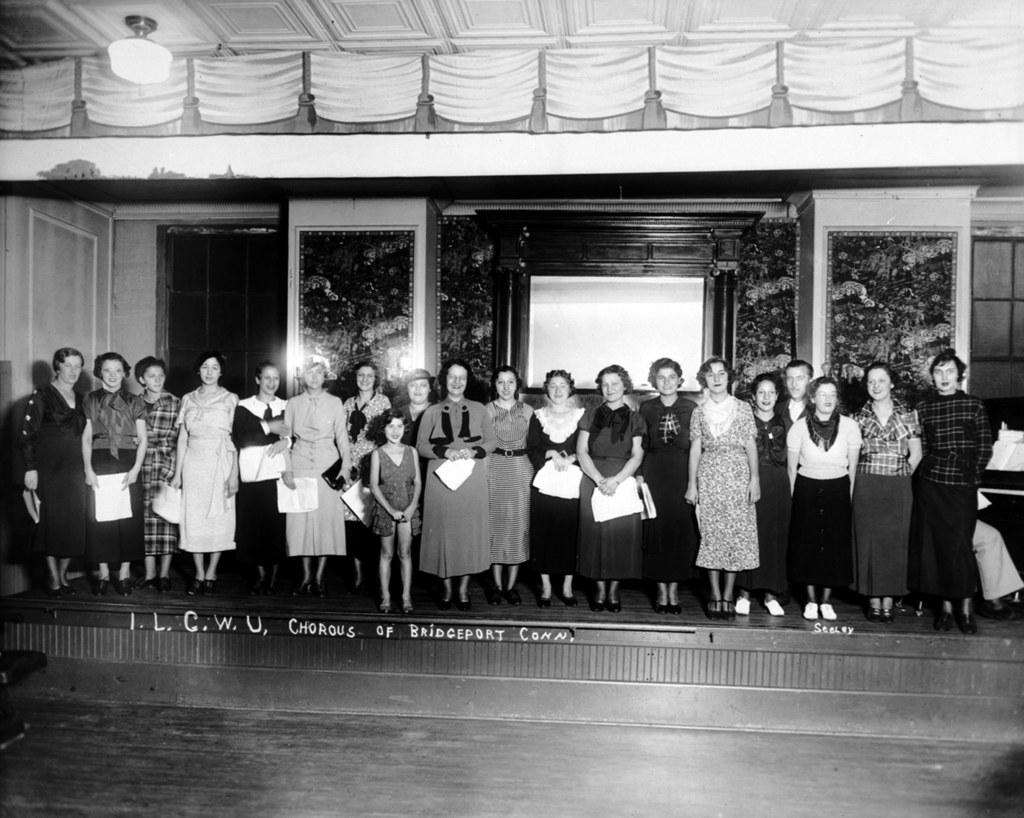What is the color scheme of the image? The image is black and white. What is happening in the image? There is a group of people in the image, and they are standing on a stage. How are the people in the image feeling? The people in the image are smiling. What can be seen in the image that provides light? There is a light in the image. What is attached to the wall in the image? There are frames attached to the wall in the image. How many wheels can be seen on the stage in the image? There are no wheels visible in the image, as it features a group of people standing on a stage. What color are the eyes of the people in the image? The image is black and white, so it is not possible to determine the color of the people's eyes. 